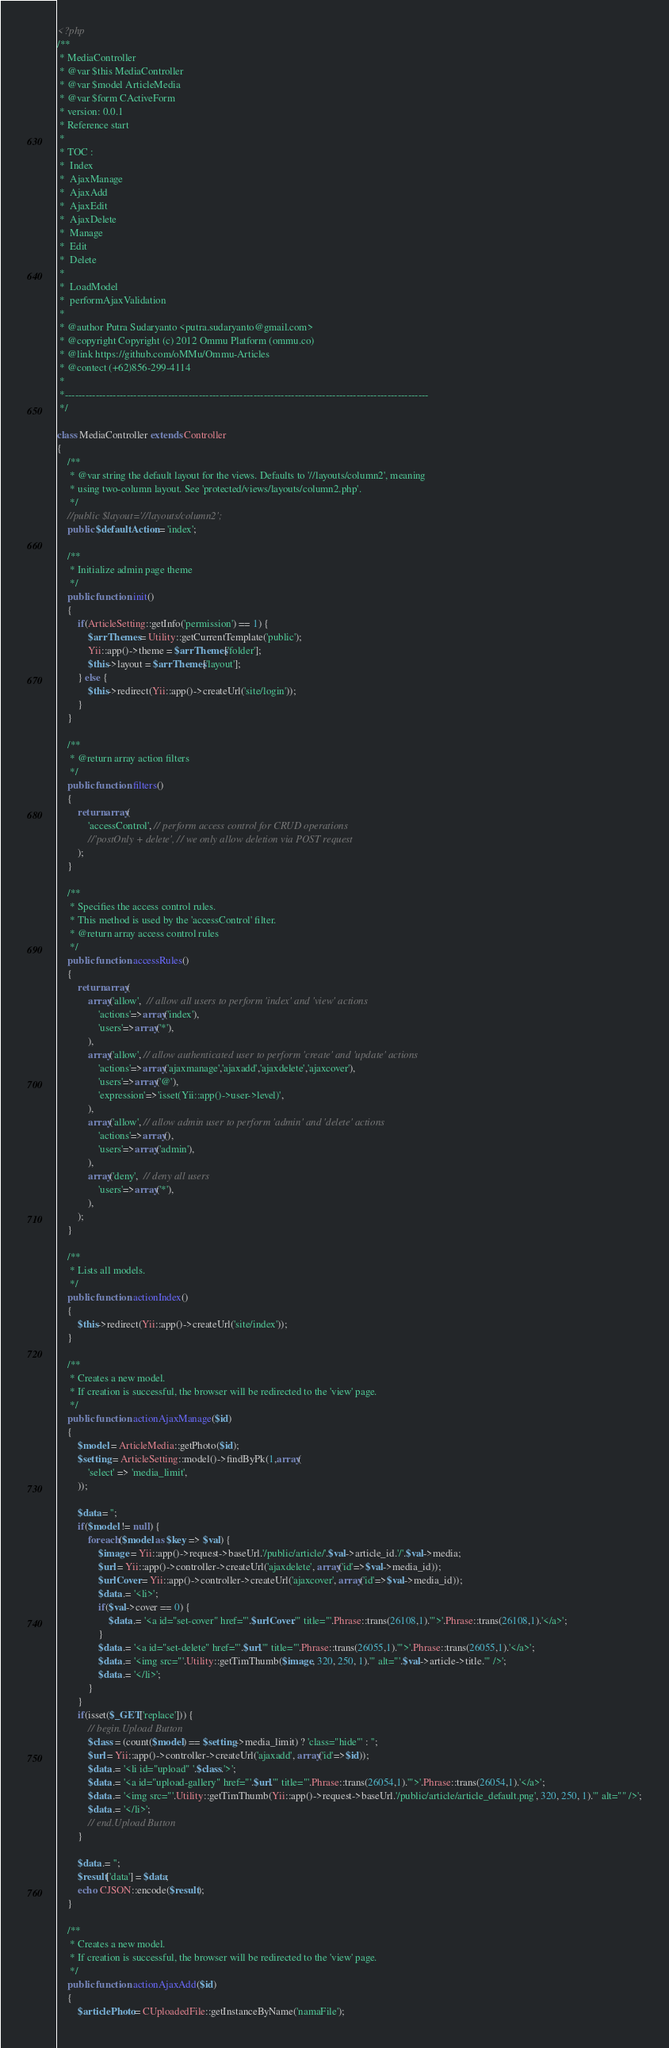Convert code to text. <code><loc_0><loc_0><loc_500><loc_500><_PHP_><?php
/**
 * MediaController
 * @var $this MediaController
 * @var $model ArticleMedia
 * @var $form CActiveForm
 * version: 0.0.1
 * Reference start
 *
 * TOC :
 *	Index
 *	AjaxManage
 *	AjaxAdd
 *	AjaxEdit
 *	AjaxDelete
 *	Manage
 *	Edit
 *	Delete
 *
 *	LoadModel
 *	performAjaxValidation
 *
 * @author Putra Sudaryanto <putra.sudaryanto@gmail.com>
 * @copyright Copyright (c) 2012 Ommu Platform (ommu.co)
 * @link https://github.com/oMMu/Ommu-Articles
 * @contect (+62)856-299-4114
 *
 *----------------------------------------------------------------------------------------------------------
 */

class MediaController extends Controller
{
	/**
	 * @var string the default layout for the views. Defaults to '//layouts/column2', meaning
	 * using two-column layout. See 'protected/views/layouts/column2.php'.
	 */
	//public $layout='//layouts/column2';
	public $defaultAction = 'index';

	/**
	 * Initialize admin page theme
	 */
	public function init() 
	{
		if(ArticleSetting::getInfo('permission') == 1) {
			$arrThemes = Utility::getCurrentTemplate('public');
			Yii::app()->theme = $arrThemes['folder'];
			$this->layout = $arrThemes['layout'];
		} else {
			$this->redirect(Yii::app()->createUrl('site/login'));
		}
	}

	/**
	 * @return array action filters
	 */
	public function filters() 
	{
		return array(
			'accessControl', // perform access control for CRUD operations
			//'postOnly + delete', // we only allow deletion via POST request
		);
	}

	/**
	 * Specifies the access control rules.
	 * This method is used by the 'accessControl' filter.
	 * @return array access control rules
	 */
	public function accessRules() 
	{
		return array(
			array('allow',  // allow all users to perform 'index' and 'view' actions
				'actions'=>array('index'),
				'users'=>array('*'),
			),
			array('allow', // allow authenticated user to perform 'create' and 'update' actions
				'actions'=>array('ajaxmanage','ajaxadd','ajaxdelete','ajaxcover'),
				'users'=>array('@'),
				'expression'=>'isset(Yii::app()->user->level)',
			),
			array('allow', // allow admin user to perform 'admin' and 'delete' actions
				'actions'=>array(),
				'users'=>array('admin'),
			),
			array('deny',  // deny all users
				'users'=>array('*'),
			),
		);
	}
	
	/**
	 * Lists all models.
	 */
	public function actionIndex() 
	{
		$this->redirect(Yii::app()->createUrl('site/index'));
	}

	/**
	 * Creates a new model.
	 * If creation is successful, the browser will be redirected to the 'view' page.
	 */
	public function actionAjaxManage($id) 
	{
		$model = ArticleMedia::getPhoto($id);
		$setting = ArticleSetting::model()->findByPk(1,array(
			'select' => 'media_limit',
		));

		$data = '';
		if($model != null) {			
			foreach($model as $key => $val) {
				$image = Yii::app()->request->baseUrl.'/public/article/'.$val->article_id.'/'.$val->media;
				$url = Yii::app()->controller->createUrl('ajaxdelete', array('id'=>$val->media_id));
				$urlCover = Yii::app()->controller->createUrl('ajaxcover', array('id'=>$val->media_id));
				$data .= '<li>';
				if($val->cover == 0) {
					$data .= '<a id="set-cover" href="'.$urlCover.'" title="'.Phrase::trans(26108,1).'">'.Phrase::trans(26108,1).'</a>';
				}
				$data .= '<a id="set-delete" href="'.$url.'" title="'.Phrase::trans(26055,1).'">'.Phrase::trans(26055,1).'</a>';
				$data .= '<img src="'.Utility::getTimThumb($image, 320, 250, 1).'" alt="'.$val->article->title.'" />';
				$data .= '</li>';
			}
		}
		if(isset($_GET['replace'])) {
			// begin.Upload Button
			$class = (count($model) == $setting->media_limit) ? 'class="hide"' : '';
			$url = Yii::app()->controller->createUrl('ajaxadd', array('id'=>$id));
			$data .= '<li id="upload" '.$class.'>';
			$data .= '<a id="upload-gallery" href="'.$url.'" title="'.Phrase::trans(26054,1).'">'.Phrase::trans(26054,1).'</a>';
			$data .= '<img src="'.Utility::getTimThumb(Yii::app()->request->baseUrl.'/public/article/article_default.png', 320, 250, 1).'" alt="" />';
			$data .= '</li>';
			// end.Upload Button
		}
		
		$data .= '';
		$result['data'] = $data;
		echo CJSON::encode($result);
	}

	/**
	 * Creates a new model.
	 * If creation is successful, the browser will be redirected to the 'view' page.
	 */
	public function actionAjaxAdd($id) 
	{
		$articlePhoto = CUploadedFile::getInstanceByName('namaFile');</code> 